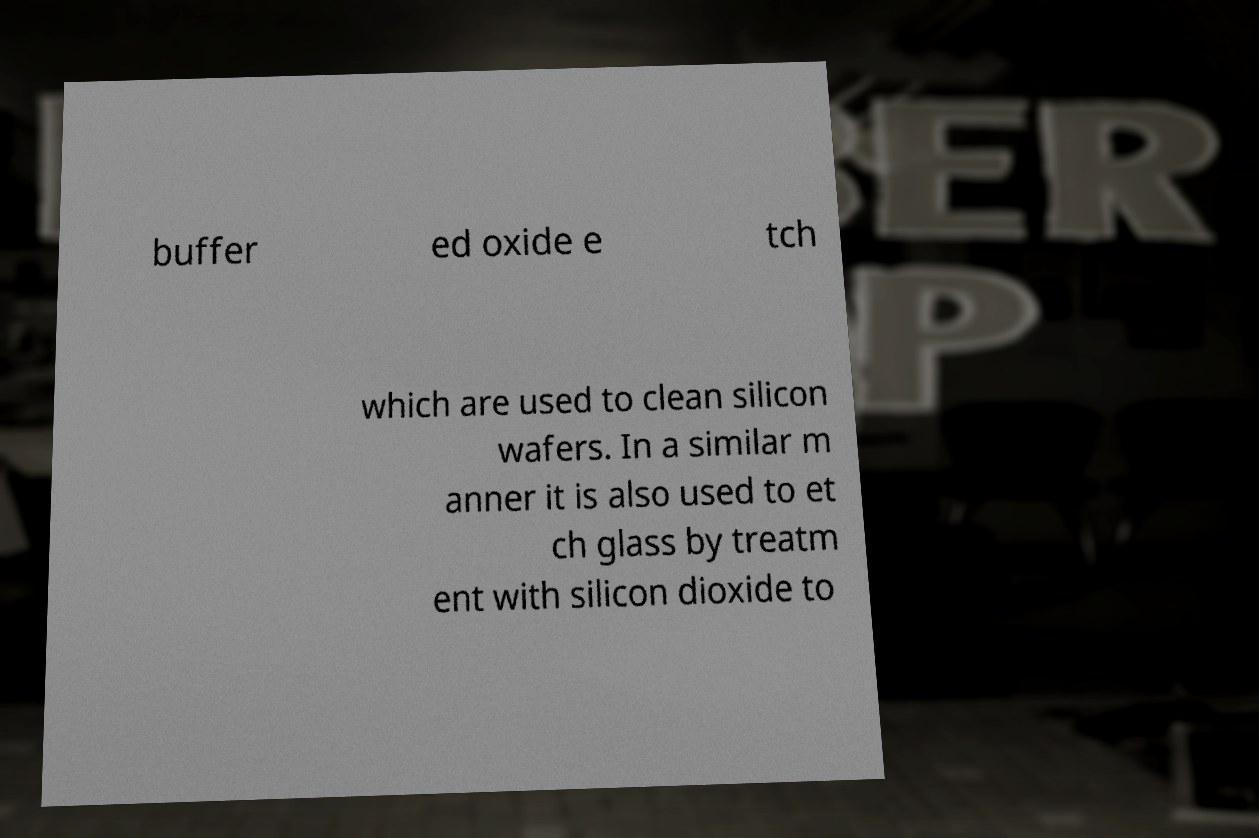For documentation purposes, I need the text within this image transcribed. Could you provide that? buffer ed oxide e tch which are used to clean silicon wafers. In a similar m anner it is also used to et ch glass by treatm ent with silicon dioxide to 